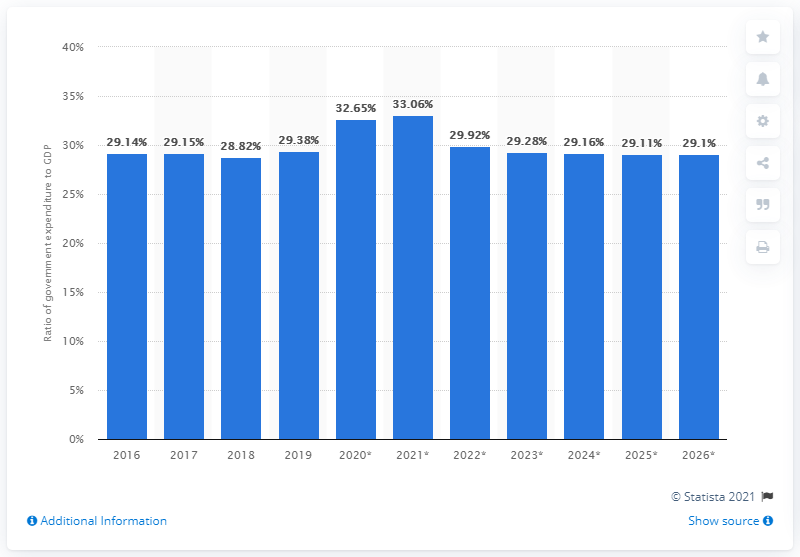Outline some significant characteristics in this image. In 2019, government expenditure accounted for 29.1% of Albania's GDP. 